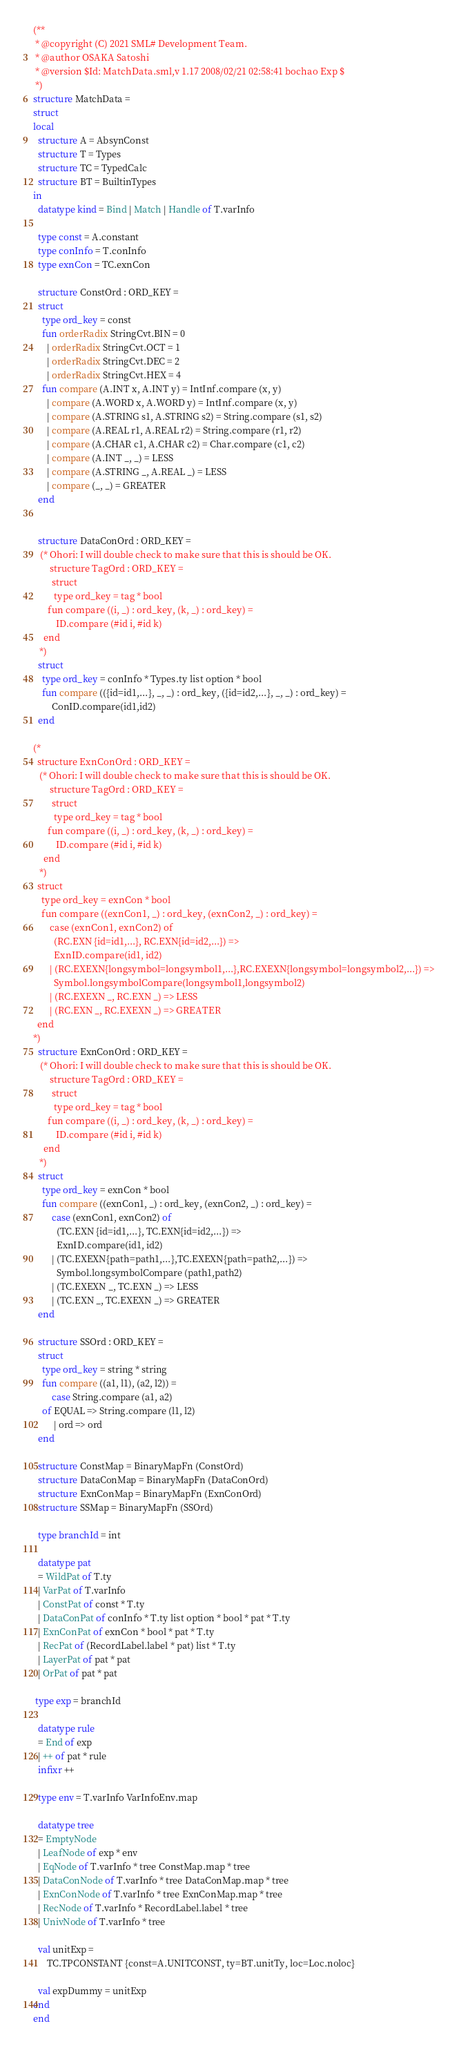<code> <loc_0><loc_0><loc_500><loc_500><_SML_>(**
 * @copyright (C) 2021 SML# Development Team.
 * @author OSAKA Satoshi
 * @version $Id: MatchData.sml,v 1.17 2008/02/21 02:58:41 bochao Exp $
 *)
structure MatchData = 
struct
local
  structure A = AbsynConst
  structure T = Types
  structure TC = TypedCalc
  structure BT = BuiltinTypes
in
  datatype kind = Bind | Match | Handle of T.varInfo
    
  type const = A.constant
  type conInfo = T.conInfo
  type exnCon = TC.exnCon

  structure ConstOrd : ORD_KEY = 
  struct
    type ord_key = const
    fun orderRadix StringCvt.BIN = 0
      | orderRadix StringCvt.OCT = 1
      | orderRadix StringCvt.DEC = 2
      | orderRadix StringCvt.HEX = 4
    fun compare (A.INT x, A.INT y) = IntInf.compare (x, y)
      | compare (A.WORD x, A.WORD y) = IntInf.compare (x, y)
      | compare (A.STRING s1, A.STRING s2) = String.compare (s1, s2)
      | compare (A.REAL r1, A.REAL r2) = String.compare (r1, r2)
      | compare (A.CHAR c1, A.CHAR c2) = Char.compare (c1, c2)
      | compare (A.INT _, _) = LESS
      | compare (A.STRING _, A.REAL _) = LESS
      | compare (_, _) = GREATER
  end


  structure DataConOrd : ORD_KEY = 
   (* Ohori: I will double check to make sure that this is should be OK.
        structure TagOrd : ORD_KEY = 
         struct
          type ord_key = tag * bool
       fun compare ((i, _) : ord_key, (k, _) : ord_key) = 
           ID.compare (#id i, #id k)
     end
   *)
  struct
    type ord_key = conInfo * Types.ty list option * bool
    fun compare (({id=id1,...}, _, _) : ord_key, ({id=id2,...}, _, _) : ord_key) =
        ConID.compare(id1,id2)
  end

(*
  structure ExnConOrd : ORD_KEY = 
   (* Ohori: I will double check to make sure that this is should be OK.
        structure TagOrd : ORD_KEY = 
         struct
          type ord_key = tag * bool
       fun compare ((i, _) : ord_key, (k, _) : ord_key) = 
           ID.compare (#id i, #id k)
     end
   *)
  struct
    type ord_key = exnCon * bool
    fun compare ((exnCon1, _) : ord_key, (exnCon2, _) : ord_key) = 
        case (exnCon1, exnCon2) of
          (RC.EXN {id=id1,...}, RC.EXN{id=id2,...}) =>
          ExnID.compare(id1, id2)
        | (RC.EXEXN{longsymbol=longsymbol1,...},RC.EXEXN{longsymbol=longsymbol2,...}) => 
          Symbol.longsymbolCompare(longsymbol1,longsymbol2)
        | (RC.EXEXN _, RC.EXN _) => LESS
        | (RC.EXN _, RC.EXEXN _) => GREATER
  end
*)
  structure ExnConOrd : ORD_KEY = 
   (* Ohori: I will double check to make sure that this is should be OK.
        structure TagOrd : ORD_KEY = 
         struct
          type ord_key = tag * bool
       fun compare ((i, _) : ord_key, (k, _) : ord_key) = 
           ID.compare (#id i, #id k)
     end
   *)
  struct
    type ord_key = exnCon * bool
    fun compare ((exnCon1, _) : ord_key, (exnCon2, _) : ord_key) =
        case (exnCon1, exnCon2) of
          (TC.EXN {id=id1,...}, TC.EXN{id=id2,...}) =>
          ExnID.compare(id1, id2)
        | (TC.EXEXN{path=path1,...},TC.EXEXN{path=path2,...}) =>
          Symbol.longsymbolCompare (path1,path2)
        | (TC.EXEXN _, TC.EXN _) => LESS
        | (TC.EXN _, TC.EXEXN _) => GREATER
  end

  structure SSOrd : ORD_KEY = 
  struct
    type ord_key = string * string
    fun compare ((a1, l1), (a2, l2)) = 
        case String.compare (a1, a2)
	of EQUAL => String.compare (l1, l2)
         | ord => ord
  end

  structure ConstMap = BinaryMapFn (ConstOrd)
  structure DataConMap = BinaryMapFn (DataConOrd)
  structure ExnConMap = BinaryMapFn (ExnConOrd)
  structure SSMap = BinaryMapFn (SSOrd)

  type branchId = int

  datatype pat
  = WildPat of T.ty
  | VarPat of T.varInfo
  | ConstPat of const * T.ty
  | DataConPat of conInfo * T.ty list option * bool * pat * T.ty
  | ExnConPat of exnCon * bool * pat * T.ty
  | RecPat of (RecordLabel.label * pat) list * T.ty
  | LayerPat of pat * pat
  | OrPat of pat * pat

 type exp = branchId

  datatype rule
  = End of exp
  | ++ of pat * rule
  infixr ++

  type env = T.varInfo VarInfoEnv.map

  datatype tree
  = EmptyNode
  | LeafNode of exp * env
  | EqNode of T.varInfo * tree ConstMap.map * tree
  | DataConNode of T.varInfo * tree DataConMap.map * tree
  | ExnConNode of T.varInfo * tree ExnConMap.map * tree
  | RecNode of T.varInfo * RecordLabel.label * tree
  | UnivNode of T.varInfo * tree

  val unitExp =
      TC.TPCONSTANT {const=A.UNITCONST, ty=BT.unitTy, loc=Loc.noloc}

  val expDummy = unitExp
end
end
</code> 